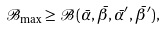Convert formula to latex. <formula><loc_0><loc_0><loc_500><loc_500>\mathcal { B } _ { \max } \geq \mathcal { B } ( \bar { \alpha } , \bar { \beta } , \bar { \alpha } ^ { \prime } , \bar { \beta } ^ { \prime } ) ,</formula> 